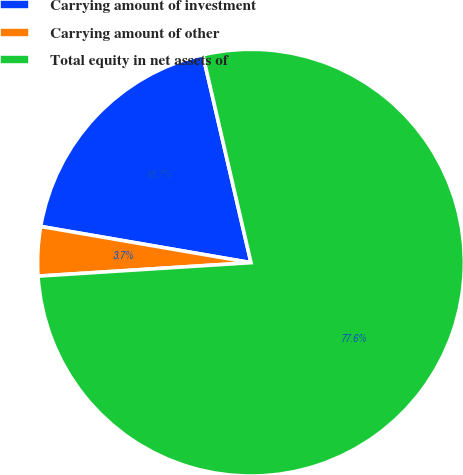Convert chart to OTSL. <chart><loc_0><loc_0><loc_500><loc_500><pie_chart><fcel>Carrying amount of investment<fcel>Carrying amount of other<fcel>Total equity in net assets of<nl><fcel>18.66%<fcel>3.72%<fcel>77.62%<nl></chart> 